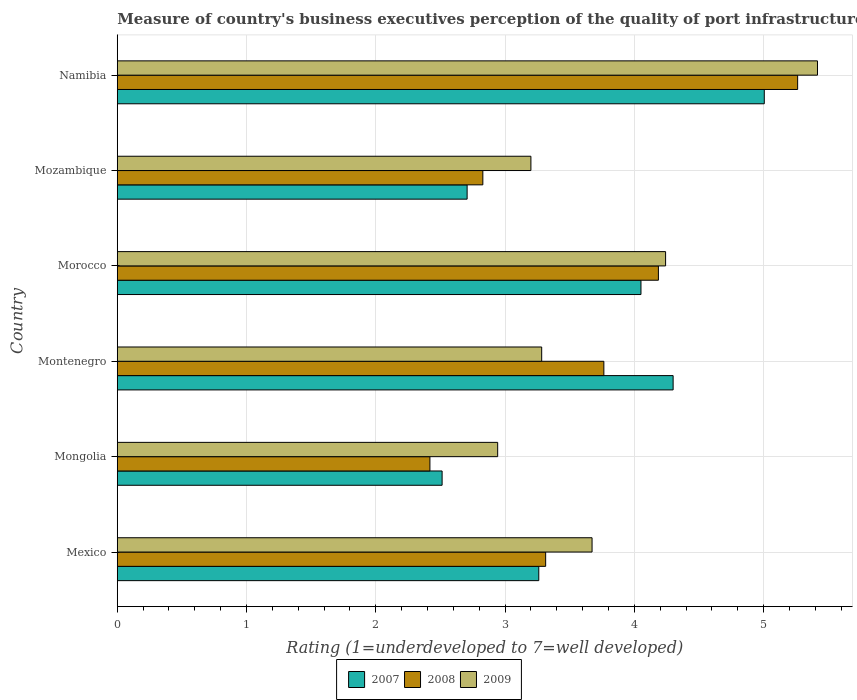How many groups of bars are there?
Offer a terse response. 6. Are the number of bars on each tick of the Y-axis equal?
Your answer should be compact. Yes. How many bars are there on the 4th tick from the top?
Ensure brevity in your answer.  3. How many bars are there on the 5th tick from the bottom?
Your answer should be compact. 3. In how many cases, is the number of bars for a given country not equal to the number of legend labels?
Offer a very short reply. 0. What is the ratings of the quality of port infrastructure in 2007 in Mozambique?
Provide a succinct answer. 2.71. Across all countries, what is the maximum ratings of the quality of port infrastructure in 2009?
Keep it short and to the point. 5.42. Across all countries, what is the minimum ratings of the quality of port infrastructure in 2009?
Your answer should be compact. 2.94. In which country was the ratings of the quality of port infrastructure in 2008 maximum?
Ensure brevity in your answer.  Namibia. In which country was the ratings of the quality of port infrastructure in 2009 minimum?
Offer a terse response. Mongolia. What is the total ratings of the quality of port infrastructure in 2009 in the graph?
Give a very brief answer. 22.76. What is the difference between the ratings of the quality of port infrastructure in 2009 in Mexico and that in Mongolia?
Your response must be concise. 0.73. What is the difference between the ratings of the quality of port infrastructure in 2007 in Namibia and the ratings of the quality of port infrastructure in 2008 in Mozambique?
Provide a succinct answer. 2.18. What is the average ratings of the quality of port infrastructure in 2007 per country?
Provide a succinct answer. 3.64. What is the difference between the ratings of the quality of port infrastructure in 2008 and ratings of the quality of port infrastructure in 2007 in Montenegro?
Your answer should be very brief. -0.54. In how many countries, is the ratings of the quality of port infrastructure in 2008 greater than 0.6000000000000001 ?
Keep it short and to the point. 6. What is the ratio of the ratings of the quality of port infrastructure in 2007 in Mozambique to that in Namibia?
Offer a terse response. 0.54. Is the ratings of the quality of port infrastructure in 2009 in Mongolia less than that in Montenegro?
Provide a short and direct response. Yes. Is the difference between the ratings of the quality of port infrastructure in 2008 in Mongolia and Mozambique greater than the difference between the ratings of the quality of port infrastructure in 2007 in Mongolia and Mozambique?
Your answer should be very brief. No. What is the difference between the highest and the second highest ratings of the quality of port infrastructure in 2008?
Ensure brevity in your answer.  1.08. What is the difference between the highest and the lowest ratings of the quality of port infrastructure in 2008?
Offer a very short reply. 2.84. In how many countries, is the ratings of the quality of port infrastructure in 2009 greater than the average ratings of the quality of port infrastructure in 2009 taken over all countries?
Make the answer very short. 2. What does the 1st bar from the top in Mongolia represents?
Your answer should be compact. 2009. What does the 1st bar from the bottom in Morocco represents?
Give a very brief answer. 2007. Is it the case that in every country, the sum of the ratings of the quality of port infrastructure in 2009 and ratings of the quality of port infrastructure in 2007 is greater than the ratings of the quality of port infrastructure in 2008?
Ensure brevity in your answer.  Yes. Are all the bars in the graph horizontal?
Provide a succinct answer. Yes. How many countries are there in the graph?
Provide a short and direct response. 6. Are the values on the major ticks of X-axis written in scientific E-notation?
Provide a succinct answer. No. Does the graph contain grids?
Your response must be concise. Yes. What is the title of the graph?
Your response must be concise. Measure of country's business executives perception of the quality of port infrastructure. What is the label or title of the X-axis?
Give a very brief answer. Rating (1=underdeveloped to 7=well developed). What is the Rating (1=underdeveloped to 7=well developed) of 2007 in Mexico?
Provide a short and direct response. 3.26. What is the Rating (1=underdeveloped to 7=well developed) of 2008 in Mexico?
Your answer should be very brief. 3.31. What is the Rating (1=underdeveloped to 7=well developed) in 2009 in Mexico?
Ensure brevity in your answer.  3.67. What is the Rating (1=underdeveloped to 7=well developed) of 2007 in Mongolia?
Keep it short and to the point. 2.51. What is the Rating (1=underdeveloped to 7=well developed) in 2008 in Mongolia?
Your response must be concise. 2.42. What is the Rating (1=underdeveloped to 7=well developed) in 2009 in Mongolia?
Make the answer very short. 2.94. What is the Rating (1=underdeveloped to 7=well developed) of 2008 in Montenegro?
Your response must be concise. 3.76. What is the Rating (1=underdeveloped to 7=well developed) in 2009 in Montenegro?
Provide a short and direct response. 3.28. What is the Rating (1=underdeveloped to 7=well developed) of 2007 in Morocco?
Keep it short and to the point. 4.05. What is the Rating (1=underdeveloped to 7=well developed) of 2008 in Morocco?
Give a very brief answer. 4.19. What is the Rating (1=underdeveloped to 7=well developed) of 2009 in Morocco?
Offer a terse response. 4.24. What is the Rating (1=underdeveloped to 7=well developed) of 2007 in Mozambique?
Make the answer very short. 2.71. What is the Rating (1=underdeveloped to 7=well developed) in 2008 in Mozambique?
Your answer should be compact. 2.83. What is the Rating (1=underdeveloped to 7=well developed) in 2009 in Mozambique?
Offer a very short reply. 3.2. What is the Rating (1=underdeveloped to 7=well developed) of 2007 in Namibia?
Keep it short and to the point. 5.01. What is the Rating (1=underdeveloped to 7=well developed) of 2008 in Namibia?
Your answer should be compact. 5.26. What is the Rating (1=underdeveloped to 7=well developed) of 2009 in Namibia?
Give a very brief answer. 5.42. Across all countries, what is the maximum Rating (1=underdeveloped to 7=well developed) of 2007?
Give a very brief answer. 5.01. Across all countries, what is the maximum Rating (1=underdeveloped to 7=well developed) in 2008?
Keep it short and to the point. 5.26. Across all countries, what is the maximum Rating (1=underdeveloped to 7=well developed) in 2009?
Your response must be concise. 5.42. Across all countries, what is the minimum Rating (1=underdeveloped to 7=well developed) in 2007?
Your answer should be compact. 2.51. Across all countries, what is the minimum Rating (1=underdeveloped to 7=well developed) in 2008?
Your answer should be very brief. 2.42. Across all countries, what is the minimum Rating (1=underdeveloped to 7=well developed) in 2009?
Your answer should be very brief. 2.94. What is the total Rating (1=underdeveloped to 7=well developed) of 2007 in the graph?
Give a very brief answer. 21.84. What is the total Rating (1=underdeveloped to 7=well developed) of 2008 in the graph?
Offer a very short reply. 21.77. What is the total Rating (1=underdeveloped to 7=well developed) of 2009 in the graph?
Give a very brief answer. 22.76. What is the difference between the Rating (1=underdeveloped to 7=well developed) in 2007 in Mexico and that in Mongolia?
Your response must be concise. 0.75. What is the difference between the Rating (1=underdeveloped to 7=well developed) of 2008 in Mexico and that in Mongolia?
Your answer should be very brief. 0.9. What is the difference between the Rating (1=underdeveloped to 7=well developed) of 2009 in Mexico and that in Mongolia?
Offer a very short reply. 0.73. What is the difference between the Rating (1=underdeveloped to 7=well developed) in 2007 in Mexico and that in Montenegro?
Your response must be concise. -1.04. What is the difference between the Rating (1=underdeveloped to 7=well developed) in 2008 in Mexico and that in Montenegro?
Your answer should be very brief. -0.45. What is the difference between the Rating (1=underdeveloped to 7=well developed) in 2009 in Mexico and that in Montenegro?
Provide a short and direct response. 0.39. What is the difference between the Rating (1=underdeveloped to 7=well developed) in 2007 in Mexico and that in Morocco?
Make the answer very short. -0.79. What is the difference between the Rating (1=underdeveloped to 7=well developed) of 2008 in Mexico and that in Morocco?
Provide a short and direct response. -0.87. What is the difference between the Rating (1=underdeveloped to 7=well developed) of 2009 in Mexico and that in Morocco?
Your answer should be very brief. -0.57. What is the difference between the Rating (1=underdeveloped to 7=well developed) in 2007 in Mexico and that in Mozambique?
Offer a terse response. 0.55. What is the difference between the Rating (1=underdeveloped to 7=well developed) of 2008 in Mexico and that in Mozambique?
Give a very brief answer. 0.49. What is the difference between the Rating (1=underdeveloped to 7=well developed) of 2009 in Mexico and that in Mozambique?
Provide a succinct answer. 0.47. What is the difference between the Rating (1=underdeveloped to 7=well developed) of 2007 in Mexico and that in Namibia?
Offer a very short reply. -1.74. What is the difference between the Rating (1=underdeveloped to 7=well developed) of 2008 in Mexico and that in Namibia?
Your response must be concise. -1.95. What is the difference between the Rating (1=underdeveloped to 7=well developed) in 2009 in Mexico and that in Namibia?
Provide a succinct answer. -1.74. What is the difference between the Rating (1=underdeveloped to 7=well developed) in 2007 in Mongolia and that in Montenegro?
Your answer should be very brief. -1.79. What is the difference between the Rating (1=underdeveloped to 7=well developed) of 2008 in Mongolia and that in Montenegro?
Your answer should be very brief. -1.35. What is the difference between the Rating (1=underdeveloped to 7=well developed) in 2009 in Mongolia and that in Montenegro?
Your answer should be compact. -0.34. What is the difference between the Rating (1=underdeveloped to 7=well developed) of 2007 in Mongolia and that in Morocco?
Your response must be concise. -1.54. What is the difference between the Rating (1=underdeveloped to 7=well developed) of 2008 in Mongolia and that in Morocco?
Provide a short and direct response. -1.77. What is the difference between the Rating (1=underdeveloped to 7=well developed) in 2009 in Mongolia and that in Morocco?
Your response must be concise. -1.3. What is the difference between the Rating (1=underdeveloped to 7=well developed) of 2007 in Mongolia and that in Mozambique?
Your answer should be compact. -0.19. What is the difference between the Rating (1=underdeveloped to 7=well developed) in 2008 in Mongolia and that in Mozambique?
Give a very brief answer. -0.41. What is the difference between the Rating (1=underdeveloped to 7=well developed) of 2009 in Mongolia and that in Mozambique?
Your answer should be compact. -0.26. What is the difference between the Rating (1=underdeveloped to 7=well developed) in 2007 in Mongolia and that in Namibia?
Ensure brevity in your answer.  -2.49. What is the difference between the Rating (1=underdeveloped to 7=well developed) of 2008 in Mongolia and that in Namibia?
Give a very brief answer. -2.84. What is the difference between the Rating (1=underdeveloped to 7=well developed) in 2009 in Mongolia and that in Namibia?
Give a very brief answer. -2.47. What is the difference between the Rating (1=underdeveloped to 7=well developed) in 2007 in Montenegro and that in Morocco?
Offer a terse response. 0.25. What is the difference between the Rating (1=underdeveloped to 7=well developed) of 2008 in Montenegro and that in Morocco?
Your answer should be very brief. -0.42. What is the difference between the Rating (1=underdeveloped to 7=well developed) of 2009 in Montenegro and that in Morocco?
Provide a short and direct response. -0.96. What is the difference between the Rating (1=underdeveloped to 7=well developed) in 2007 in Montenegro and that in Mozambique?
Keep it short and to the point. 1.59. What is the difference between the Rating (1=underdeveloped to 7=well developed) in 2008 in Montenegro and that in Mozambique?
Keep it short and to the point. 0.94. What is the difference between the Rating (1=underdeveloped to 7=well developed) of 2009 in Montenegro and that in Mozambique?
Your response must be concise. 0.08. What is the difference between the Rating (1=underdeveloped to 7=well developed) in 2007 in Montenegro and that in Namibia?
Make the answer very short. -0.71. What is the difference between the Rating (1=underdeveloped to 7=well developed) of 2008 in Montenegro and that in Namibia?
Your response must be concise. -1.5. What is the difference between the Rating (1=underdeveloped to 7=well developed) in 2009 in Montenegro and that in Namibia?
Provide a short and direct response. -2.13. What is the difference between the Rating (1=underdeveloped to 7=well developed) in 2007 in Morocco and that in Mozambique?
Ensure brevity in your answer.  1.34. What is the difference between the Rating (1=underdeveloped to 7=well developed) of 2008 in Morocco and that in Mozambique?
Your answer should be very brief. 1.36. What is the difference between the Rating (1=underdeveloped to 7=well developed) in 2009 in Morocco and that in Mozambique?
Your response must be concise. 1.04. What is the difference between the Rating (1=underdeveloped to 7=well developed) of 2007 in Morocco and that in Namibia?
Make the answer very short. -0.95. What is the difference between the Rating (1=underdeveloped to 7=well developed) in 2008 in Morocco and that in Namibia?
Offer a terse response. -1.08. What is the difference between the Rating (1=underdeveloped to 7=well developed) of 2009 in Morocco and that in Namibia?
Your answer should be very brief. -1.18. What is the difference between the Rating (1=underdeveloped to 7=well developed) in 2007 in Mozambique and that in Namibia?
Ensure brevity in your answer.  -2.3. What is the difference between the Rating (1=underdeveloped to 7=well developed) in 2008 in Mozambique and that in Namibia?
Provide a succinct answer. -2.44. What is the difference between the Rating (1=underdeveloped to 7=well developed) in 2009 in Mozambique and that in Namibia?
Your answer should be very brief. -2.22. What is the difference between the Rating (1=underdeveloped to 7=well developed) of 2007 in Mexico and the Rating (1=underdeveloped to 7=well developed) of 2008 in Mongolia?
Offer a terse response. 0.84. What is the difference between the Rating (1=underdeveloped to 7=well developed) in 2007 in Mexico and the Rating (1=underdeveloped to 7=well developed) in 2009 in Mongolia?
Give a very brief answer. 0.32. What is the difference between the Rating (1=underdeveloped to 7=well developed) of 2008 in Mexico and the Rating (1=underdeveloped to 7=well developed) of 2009 in Mongolia?
Keep it short and to the point. 0.37. What is the difference between the Rating (1=underdeveloped to 7=well developed) in 2007 in Mexico and the Rating (1=underdeveloped to 7=well developed) in 2008 in Montenegro?
Offer a very short reply. -0.5. What is the difference between the Rating (1=underdeveloped to 7=well developed) in 2007 in Mexico and the Rating (1=underdeveloped to 7=well developed) in 2009 in Montenegro?
Offer a very short reply. -0.02. What is the difference between the Rating (1=underdeveloped to 7=well developed) in 2008 in Mexico and the Rating (1=underdeveloped to 7=well developed) in 2009 in Montenegro?
Give a very brief answer. 0.03. What is the difference between the Rating (1=underdeveloped to 7=well developed) in 2007 in Mexico and the Rating (1=underdeveloped to 7=well developed) in 2008 in Morocco?
Keep it short and to the point. -0.93. What is the difference between the Rating (1=underdeveloped to 7=well developed) in 2007 in Mexico and the Rating (1=underdeveloped to 7=well developed) in 2009 in Morocco?
Offer a very short reply. -0.98. What is the difference between the Rating (1=underdeveloped to 7=well developed) in 2008 in Mexico and the Rating (1=underdeveloped to 7=well developed) in 2009 in Morocco?
Ensure brevity in your answer.  -0.93. What is the difference between the Rating (1=underdeveloped to 7=well developed) of 2007 in Mexico and the Rating (1=underdeveloped to 7=well developed) of 2008 in Mozambique?
Your response must be concise. 0.43. What is the difference between the Rating (1=underdeveloped to 7=well developed) of 2007 in Mexico and the Rating (1=underdeveloped to 7=well developed) of 2009 in Mozambique?
Provide a short and direct response. 0.06. What is the difference between the Rating (1=underdeveloped to 7=well developed) of 2008 in Mexico and the Rating (1=underdeveloped to 7=well developed) of 2009 in Mozambique?
Provide a short and direct response. 0.11. What is the difference between the Rating (1=underdeveloped to 7=well developed) of 2007 in Mexico and the Rating (1=underdeveloped to 7=well developed) of 2008 in Namibia?
Provide a short and direct response. -2. What is the difference between the Rating (1=underdeveloped to 7=well developed) of 2007 in Mexico and the Rating (1=underdeveloped to 7=well developed) of 2009 in Namibia?
Your response must be concise. -2.16. What is the difference between the Rating (1=underdeveloped to 7=well developed) in 2008 in Mexico and the Rating (1=underdeveloped to 7=well developed) in 2009 in Namibia?
Keep it short and to the point. -2.1. What is the difference between the Rating (1=underdeveloped to 7=well developed) in 2007 in Mongolia and the Rating (1=underdeveloped to 7=well developed) in 2008 in Montenegro?
Offer a very short reply. -1.25. What is the difference between the Rating (1=underdeveloped to 7=well developed) of 2007 in Mongolia and the Rating (1=underdeveloped to 7=well developed) of 2009 in Montenegro?
Ensure brevity in your answer.  -0.77. What is the difference between the Rating (1=underdeveloped to 7=well developed) of 2008 in Mongolia and the Rating (1=underdeveloped to 7=well developed) of 2009 in Montenegro?
Your response must be concise. -0.86. What is the difference between the Rating (1=underdeveloped to 7=well developed) in 2007 in Mongolia and the Rating (1=underdeveloped to 7=well developed) in 2008 in Morocco?
Offer a terse response. -1.67. What is the difference between the Rating (1=underdeveloped to 7=well developed) of 2007 in Mongolia and the Rating (1=underdeveloped to 7=well developed) of 2009 in Morocco?
Offer a very short reply. -1.73. What is the difference between the Rating (1=underdeveloped to 7=well developed) of 2008 in Mongolia and the Rating (1=underdeveloped to 7=well developed) of 2009 in Morocco?
Your response must be concise. -1.82. What is the difference between the Rating (1=underdeveloped to 7=well developed) of 2007 in Mongolia and the Rating (1=underdeveloped to 7=well developed) of 2008 in Mozambique?
Provide a succinct answer. -0.32. What is the difference between the Rating (1=underdeveloped to 7=well developed) of 2007 in Mongolia and the Rating (1=underdeveloped to 7=well developed) of 2009 in Mozambique?
Your answer should be compact. -0.69. What is the difference between the Rating (1=underdeveloped to 7=well developed) of 2008 in Mongolia and the Rating (1=underdeveloped to 7=well developed) of 2009 in Mozambique?
Your response must be concise. -0.78. What is the difference between the Rating (1=underdeveloped to 7=well developed) in 2007 in Mongolia and the Rating (1=underdeveloped to 7=well developed) in 2008 in Namibia?
Provide a succinct answer. -2.75. What is the difference between the Rating (1=underdeveloped to 7=well developed) of 2007 in Mongolia and the Rating (1=underdeveloped to 7=well developed) of 2009 in Namibia?
Your answer should be very brief. -2.9. What is the difference between the Rating (1=underdeveloped to 7=well developed) in 2008 in Mongolia and the Rating (1=underdeveloped to 7=well developed) in 2009 in Namibia?
Make the answer very short. -3. What is the difference between the Rating (1=underdeveloped to 7=well developed) of 2007 in Montenegro and the Rating (1=underdeveloped to 7=well developed) of 2008 in Morocco?
Ensure brevity in your answer.  0.11. What is the difference between the Rating (1=underdeveloped to 7=well developed) of 2007 in Montenegro and the Rating (1=underdeveloped to 7=well developed) of 2009 in Morocco?
Offer a terse response. 0.06. What is the difference between the Rating (1=underdeveloped to 7=well developed) of 2008 in Montenegro and the Rating (1=underdeveloped to 7=well developed) of 2009 in Morocco?
Your answer should be compact. -0.48. What is the difference between the Rating (1=underdeveloped to 7=well developed) of 2007 in Montenegro and the Rating (1=underdeveloped to 7=well developed) of 2008 in Mozambique?
Your answer should be compact. 1.47. What is the difference between the Rating (1=underdeveloped to 7=well developed) in 2007 in Montenegro and the Rating (1=underdeveloped to 7=well developed) in 2009 in Mozambique?
Keep it short and to the point. 1.1. What is the difference between the Rating (1=underdeveloped to 7=well developed) in 2008 in Montenegro and the Rating (1=underdeveloped to 7=well developed) in 2009 in Mozambique?
Offer a very short reply. 0.56. What is the difference between the Rating (1=underdeveloped to 7=well developed) of 2007 in Montenegro and the Rating (1=underdeveloped to 7=well developed) of 2008 in Namibia?
Offer a terse response. -0.96. What is the difference between the Rating (1=underdeveloped to 7=well developed) of 2007 in Montenegro and the Rating (1=underdeveloped to 7=well developed) of 2009 in Namibia?
Ensure brevity in your answer.  -1.12. What is the difference between the Rating (1=underdeveloped to 7=well developed) in 2008 in Montenegro and the Rating (1=underdeveloped to 7=well developed) in 2009 in Namibia?
Offer a very short reply. -1.65. What is the difference between the Rating (1=underdeveloped to 7=well developed) in 2007 in Morocco and the Rating (1=underdeveloped to 7=well developed) in 2008 in Mozambique?
Offer a very short reply. 1.22. What is the difference between the Rating (1=underdeveloped to 7=well developed) in 2007 in Morocco and the Rating (1=underdeveloped to 7=well developed) in 2009 in Mozambique?
Provide a succinct answer. 0.85. What is the difference between the Rating (1=underdeveloped to 7=well developed) in 2008 in Morocco and the Rating (1=underdeveloped to 7=well developed) in 2009 in Mozambique?
Your answer should be very brief. 0.99. What is the difference between the Rating (1=underdeveloped to 7=well developed) in 2007 in Morocco and the Rating (1=underdeveloped to 7=well developed) in 2008 in Namibia?
Offer a very short reply. -1.21. What is the difference between the Rating (1=underdeveloped to 7=well developed) of 2007 in Morocco and the Rating (1=underdeveloped to 7=well developed) of 2009 in Namibia?
Your answer should be compact. -1.37. What is the difference between the Rating (1=underdeveloped to 7=well developed) of 2008 in Morocco and the Rating (1=underdeveloped to 7=well developed) of 2009 in Namibia?
Keep it short and to the point. -1.23. What is the difference between the Rating (1=underdeveloped to 7=well developed) in 2007 in Mozambique and the Rating (1=underdeveloped to 7=well developed) in 2008 in Namibia?
Ensure brevity in your answer.  -2.56. What is the difference between the Rating (1=underdeveloped to 7=well developed) of 2007 in Mozambique and the Rating (1=underdeveloped to 7=well developed) of 2009 in Namibia?
Ensure brevity in your answer.  -2.71. What is the difference between the Rating (1=underdeveloped to 7=well developed) of 2008 in Mozambique and the Rating (1=underdeveloped to 7=well developed) of 2009 in Namibia?
Ensure brevity in your answer.  -2.59. What is the average Rating (1=underdeveloped to 7=well developed) in 2007 per country?
Your answer should be very brief. 3.64. What is the average Rating (1=underdeveloped to 7=well developed) in 2008 per country?
Keep it short and to the point. 3.63. What is the average Rating (1=underdeveloped to 7=well developed) in 2009 per country?
Your answer should be compact. 3.79. What is the difference between the Rating (1=underdeveloped to 7=well developed) in 2007 and Rating (1=underdeveloped to 7=well developed) in 2008 in Mexico?
Provide a short and direct response. -0.05. What is the difference between the Rating (1=underdeveloped to 7=well developed) in 2007 and Rating (1=underdeveloped to 7=well developed) in 2009 in Mexico?
Provide a succinct answer. -0.41. What is the difference between the Rating (1=underdeveloped to 7=well developed) of 2008 and Rating (1=underdeveloped to 7=well developed) of 2009 in Mexico?
Your response must be concise. -0.36. What is the difference between the Rating (1=underdeveloped to 7=well developed) of 2007 and Rating (1=underdeveloped to 7=well developed) of 2008 in Mongolia?
Offer a terse response. 0.09. What is the difference between the Rating (1=underdeveloped to 7=well developed) in 2007 and Rating (1=underdeveloped to 7=well developed) in 2009 in Mongolia?
Provide a succinct answer. -0.43. What is the difference between the Rating (1=underdeveloped to 7=well developed) in 2008 and Rating (1=underdeveloped to 7=well developed) in 2009 in Mongolia?
Offer a very short reply. -0.52. What is the difference between the Rating (1=underdeveloped to 7=well developed) in 2007 and Rating (1=underdeveloped to 7=well developed) in 2008 in Montenegro?
Your response must be concise. 0.54. What is the difference between the Rating (1=underdeveloped to 7=well developed) of 2007 and Rating (1=underdeveloped to 7=well developed) of 2009 in Montenegro?
Your answer should be compact. 1.02. What is the difference between the Rating (1=underdeveloped to 7=well developed) of 2008 and Rating (1=underdeveloped to 7=well developed) of 2009 in Montenegro?
Provide a short and direct response. 0.48. What is the difference between the Rating (1=underdeveloped to 7=well developed) in 2007 and Rating (1=underdeveloped to 7=well developed) in 2008 in Morocco?
Offer a terse response. -0.13. What is the difference between the Rating (1=underdeveloped to 7=well developed) in 2007 and Rating (1=underdeveloped to 7=well developed) in 2009 in Morocco?
Offer a terse response. -0.19. What is the difference between the Rating (1=underdeveloped to 7=well developed) of 2008 and Rating (1=underdeveloped to 7=well developed) of 2009 in Morocco?
Your answer should be compact. -0.06. What is the difference between the Rating (1=underdeveloped to 7=well developed) in 2007 and Rating (1=underdeveloped to 7=well developed) in 2008 in Mozambique?
Keep it short and to the point. -0.12. What is the difference between the Rating (1=underdeveloped to 7=well developed) in 2007 and Rating (1=underdeveloped to 7=well developed) in 2009 in Mozambique?
Your answer should be compact. -0.49. What is the difference between the Rating (1=underdeveloped to 7=well developed) of 2008 and Rating (1=underdeveloped to 7=well developed) of 2009 in Mozambique?
Your answer should be very brief. -0.37. What is the difference between the Rating (1=underdeveloped to 7=well developed) of 2007 and Rating (1=underdeveloped to 7=well developed) of 2008 in Namibia?
Ensure brevity in your answer.  -0.26. What is the difference between the Rating (1=underdeveloped to 7=well developed) of 2007 and Rating (1=underdeveloped to 7=well developed) of 2009 in Namibia?
Offer a very short reply. -0.41. What is the difference between the Rating (1=underdeveloped to 7=well developed) in 2008 and Rating (1=underdeveloped to 7=well developed) in 2009 in Namibia?
Offer a very short reply. -0.15. What is the ratio of the Rating (1=underdeveloped to 7=well developed) in 2007 in Mexico to that in Mongolia?
Ensure brevity in your answer.  1.3. What is the ratio of the Rating (1=underdeveloped to 7=well developed) of 2008 in Mexico to that in Mongolia?
Your answer should be compact. 1.37. What is the ratio of the Rating (1=underdeveloped to 7=well developed) of 2009 in Mexico to that in Mongolia?
Offer a terse response. 1.25. What is the ratio of the Rating (1=underdeveloped to 7=well developed) in 2007 in Mexico to that in Montenegro?
Ensure brevity in your answer.  0.76. What is the ratio of the Rating (1=underdeveloped to 7=well developed) of 2008 in Mexico to that in Montenegro?
Provide a succinct answer. 0.88. What is the ratio of the Rating (1=underdeveloped to 7=well developed) of 2009 in Mexico to that in Montenegro?
Offer a very short reply. 1.12. What is the ratio of the Rating (1=underdeveloped to 7=well developed) in 2007 in Mexico to that in Morocco?
Offer a terse response. 0.8. What is the ratio of the Rating (1=underdeveloped to 7=well developed) of 2008 in Mexico to that in Morocco?
Your response must be concise. 0.79. What is the ratio of the Rating (1=underdeveloped to 7=well developed) in 2009 in Mexico to that in Morocco?
Give a very brief answer. 0.87. What is the ratio of the Rating (1=underdeveloped to 7=well developed) of 2007 in Mexico to that in Mozambique?
Ensure brevity in your answer.  1.2. What is the ratio of the Rating (1=underdeveloped to 7=well developed) of 2008 in Mexico to that in Mozambique?
Make the answer very short. 1.17. What is the ratio of the Rating (1=underdeveloped to 7=well developed) in 2009 in Mexico to that in Mozambique?
Provide a short and direct response. 1.15. What is the ratio of the Rating (1=underdeveloped to 7=well developed) of 2007 in Mexico to that in Namibia?
Offer a terse response. 0.65. What is the ratio of the Rating (1=underdeveloped to 7=well developed) in 2008 in Mexico to that in Namibia?
Give a very brief answer. 0.63. What is the ratio of the Rating (1=underdeveloped to 7=well developed) of 2009 in Mexico to that in Namibia?
Offer a terse response. 0.68. What is the ratio of the Rating (1=underdeveloped to 7=well developed) of 2007 in Mongolia to that in Montenegro?
Provide a succinct answer. 0.58. What is the ratio of the Rating (1=underdeveloped to 7=well developed) in 2008 in Mongolia to that in Montenegro?
Offer a very short reply. 0.64. What is the ratio of the Rating (1=underdeveloped to 7=well developed) of 2009 in Mongolia to that in Montenegro?
Ensure brevity in your answer.  0.9. What is the ratio of the Rating (1=underdeveloped to 7=well developed) in 2007 in Mongolia to that in Morocco?
Your answer should be compact. 0.62. What is the ratio of the Rating (1=underdeveloped to 7=well developed) in 2008 in Mongolia to that in Morocco?
Give a very brief answer. 0.58. What is the ratio of the Rating (1=underdeveloped to 7=well developed) of 2009 in Mongolia to that in Morocco?
Provide a short and direct response. 0.69. What is the ratio of the Rating (1=underdeveloped to 7=well developed) of 2007 in Mongolia to that in Mozambique?
Give a very brief answer. 0.93. What is the ratio of the Rating (1=underdeveloped to 7=well developed) of 2008 in Mongolia to that in Mozambique?
Ensure brevity in your answer.  0.86. What is the ratio of the Rating (1=underdeveloped to 7=well developed) in 2009 in Mongolia to that in Mozambique?
Give a very brief answer. 0.92. What is the ratio of the Rating (1=underdeveloped to 7=well developed) of 2007 in Mongolia to that in Namibia?
Ensure brevity in your answer.  0.5. What is the ratio of the Rating (1=underdeveloped to 7=well developed) of 2008 in Mongolia to that in Namibia?
Provide a succinct answer. 0.46. What is the ratio of the Rating (1=underdeveloped to 7=well developed) of 2009 in Mongolia to that in Namibia?
Ensure brevity in your answer.  0.54. What is the ratio of the Rating (1=underdeveloped to 7=well developed) in 2007 in Montenegro to that in Morocco?
Your response must be concise. 1.06. What is the ratio of the Rating (1=underdeveloped to 7=well developed) of 2008 in Montenegro to that in Morocco?
Give a very brief answer. 0.9. What is the ratio of the Rating (1=underdeveloped to 7=well developed) of 2009 in Montenegro to that in Morocco?
Ensure brevity in your answer.  0.77. What is the ratio of the Rating (1=underdeveloped to 7=well developed) in 2007 in Montenegro to that in Mozambique?
Ensure brevity in your answer.  1.59. What is the ratio of the Rating (1=underdeveloped to 7=well developed) in 2008 in Montenegro to that in Mozambique?
Ensure brevity in your answer.  1.33. What is the ratio of the Rating (1=underdeveloped to 7=well developed) in 2009 in Montenegro to that in Mozambique?
Offer a terse response. 1.03. What is the ratio of the Rating (1=underdeveloped to 7=well developed) in 2007 in Montenegro to that in Namibia?
Your answer should be very brief. 0.86. What is the ratio of the Rating (1=underdeveloped to 7=well developed) of 2008 in Montenegro to that in Namibia?
Provide a succinct answer. 0.72. What is the ratio of the Rating (1=underdeveloped to 7=well developed) of 2009 in Montenegro to that in Namibia?
Provide a short and direct response. 0.61. What is the ratio of the Rating (1=underdeveloped to 7=well developed) in 2007 in Morocco to that in Mozambique?
Provide a succinct answer. 1.5. What is the ratio of the Rating (1=underdeveloped to 7=well developed) in 2008 in Morocco to that in Mozambique?
Offer a terse response. 1.48. What is the ratio of the Rating (1=underdeveloped to 7=well developed) of 2009 in Morocco to that in Mozambique?
Provide a short and direct response. 1.33. What is the ratio of the Rating (1=underdeveloped to 7=well developed) of 2007 in Morocco to that in Namibia?
Keep it short and to the point. 0.81. What is the ratio of the Rating (1=underdeveloped to 7=well developed) of 2008 in Morocco to that in Namibia?
Give a very brief answer. 0.8. What is the ratio of the Rating (1=underdeveloped to 7=well developed) of 2009 in Morocco to that in Namibia?
Offer a terse response. 0.78. What is the ratio of the Rating (1=underdeveloped to 7=well developed) of 2007 in Mozambique to that in Namibia?
Keep it short and to the point. 0.54. What is the ratio of the Rating (1=underdeveloped to 7=well developed) in 2008 in Mozambique to that in Namibia?
Provide a short and direct response. 0.54. What is the ratio of the Rating (1=underdeveloped to 7=well developed) of 2009 in Mozambique to that in Namibia?
Keep it short and to the point. 0.59. What is the difference between the highest and the second highest Rating (1=underdeveloped to 7=well developed) of 2007?
Your response must be concise. 0.71. What is the difference between the highest and the second highest Rating (1=underdeveloped to 7=well developed) of 2008?
Your answer should be compact. 1.08. What is the difference between the highest and the second highest Rating (1=underdeveloped to 7=well developed) in 2009?
Keep it short and to the point. 1.18. What is the difference between the highest and the lowest Rating (1=underdeveloped to 7=well developed) of 2007?
Make the answer very short. 2.49. What is the difference between the highest and the lowest Rating (1=underdeveloped to 7=well developed) in 2008?
Make the answer very short. 2.84. What is the difference between the highest and the lowest Rating (1=underdeveloped to 7=well developed) in 2009?
Your answer should be compact. 2.47. 